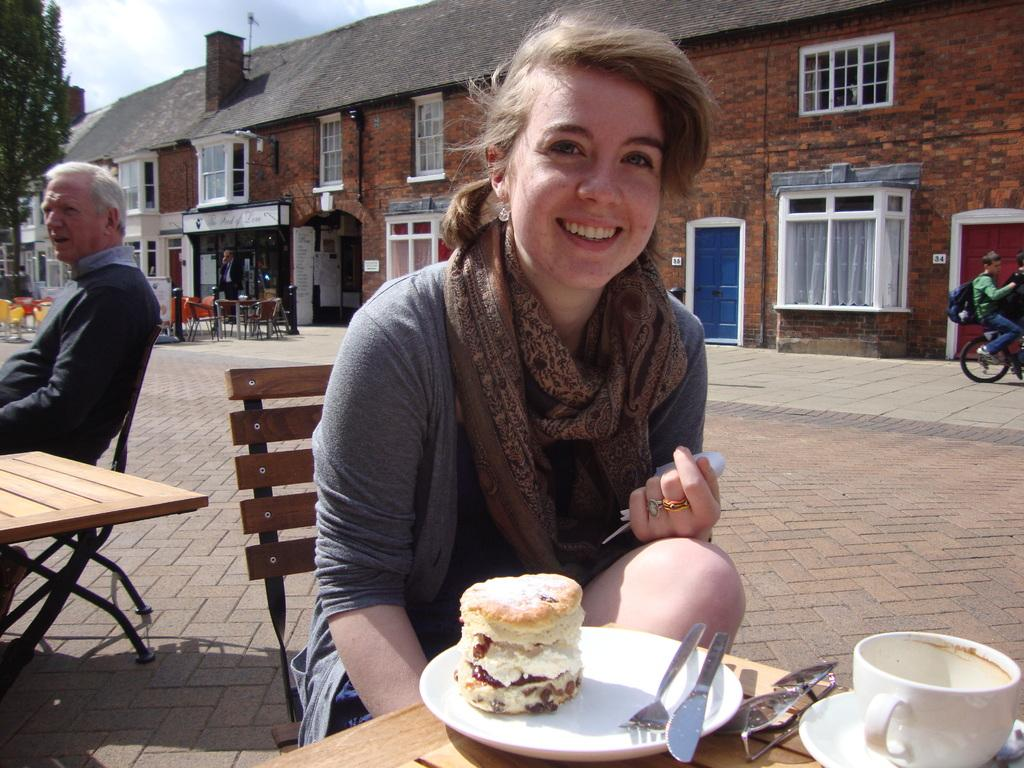What is the woman doing in the image? The woman is sitting at a table in the image. What is on the table in front of the woman? The woman has a cake on a plate in front of her. Is there anyone else in the image? Yes, there is an old man sitting at a table behind the woman. What type of oil is being used to sort the woman's belongings in the image? There is no oil or sorting activity present in the image. 